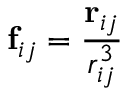Convert formula to latex. <formula><loc_0><loc_0><loc_500><loc_500>f _ { i j } = \frac { r _ { i j } } { r _ { i j } ^ { 3 } }</formula> 